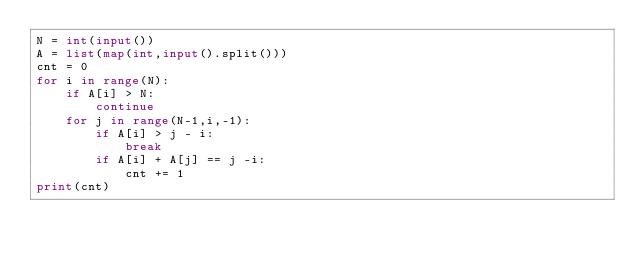Convert code to text. <code><loc_0><loc_0><loc_500><loc_500><_Python_>N = int(input())
A = list(map(int,input().split()))
cnt = 0
for i in range(N):
    if A[i] > N:
        continue
    for j in range(N-1,i,-1):
        if A[i] > j - i:
            break
        if A[i] + A[j] == j -i:
            cnt += 1
print(cnt)</code> 